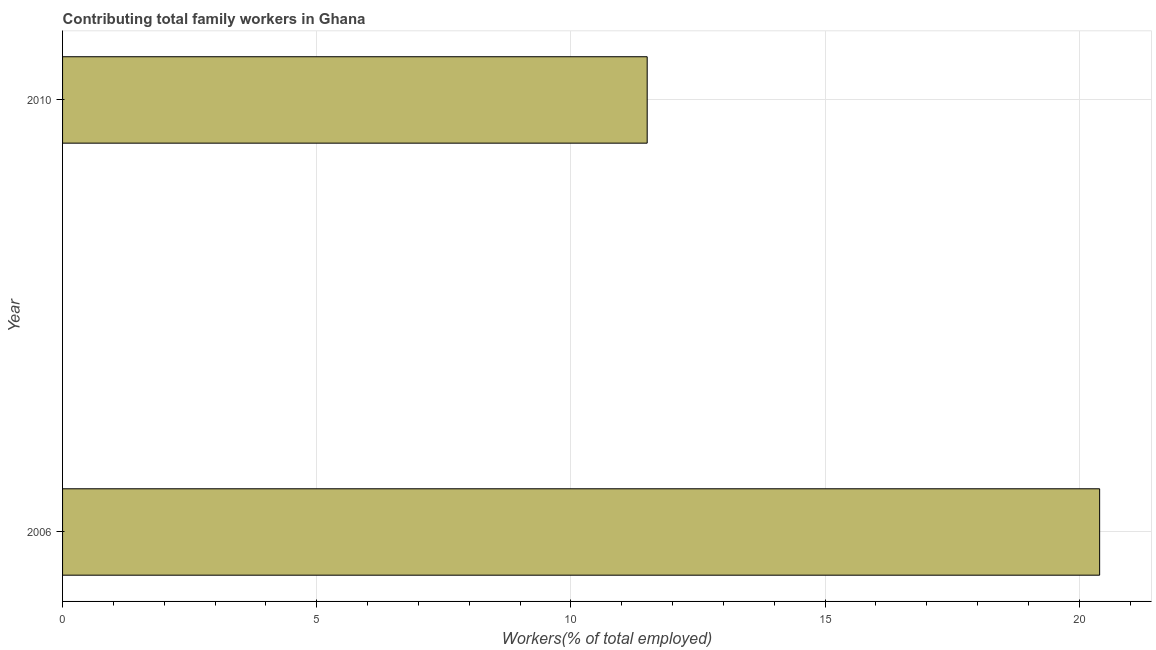Does the graph contain any zero values?
Keep it short and to the point. No. Does the graph contain grids?
Your answer should be very brief. Yes. What is the title of the graph?
Keep it short and to the point. Contributing total family workers in Ghana. What is the label or title of the X-axis?
Make the answer very short. Workers(% of total employed). Across all years, what is the maximum contributing family workers?
Your answer should be compact. 20.4. Across all years, what is the minimum contributing family workers?
Make the answer very short. 11.5. In which year was the contributing family workers maximum?
Your answer should be compact. 2006. In which year was the contributing family workers minimum?
Your response must be concise. 2010. What is the sum of the contributing family workers?
Your answer should be compact. 31.9. What is the difference between the contributing family workers in 2006 and 2010?
Offer a very short reply. 8.9. What is the average contributing family workers per year?
Your answer should be very brief. 15.95. What is the median contributing family workers?
Make the answer very short. 15.95. Do a majority of the years between 2006 and 2010 (inclusive) have contributing family workers greater than 3 %?
Provide a short and direct response. Yes. What is the ratio of the contributing family workers in 2006 to that in 2010?
Your answer should be compact. 1.77. Are the values on the major ticks of X-axis written in scientific E-notation?
Offer a terse response. No. What is the Workers(% of total employed) in 2006?
Keep it short and to the point. 20.4. What is the Workers(% of total employed) in 2010?
Your response must be concise. 11.5. What is the difference between the Workers(% of total employed) in 2006 and 2010?
Offer a terse response. 8.9. What is the ratio of the Workers(% of total employed) in 2006 to that in 2010?
Your answer should be compact. 1.77. 